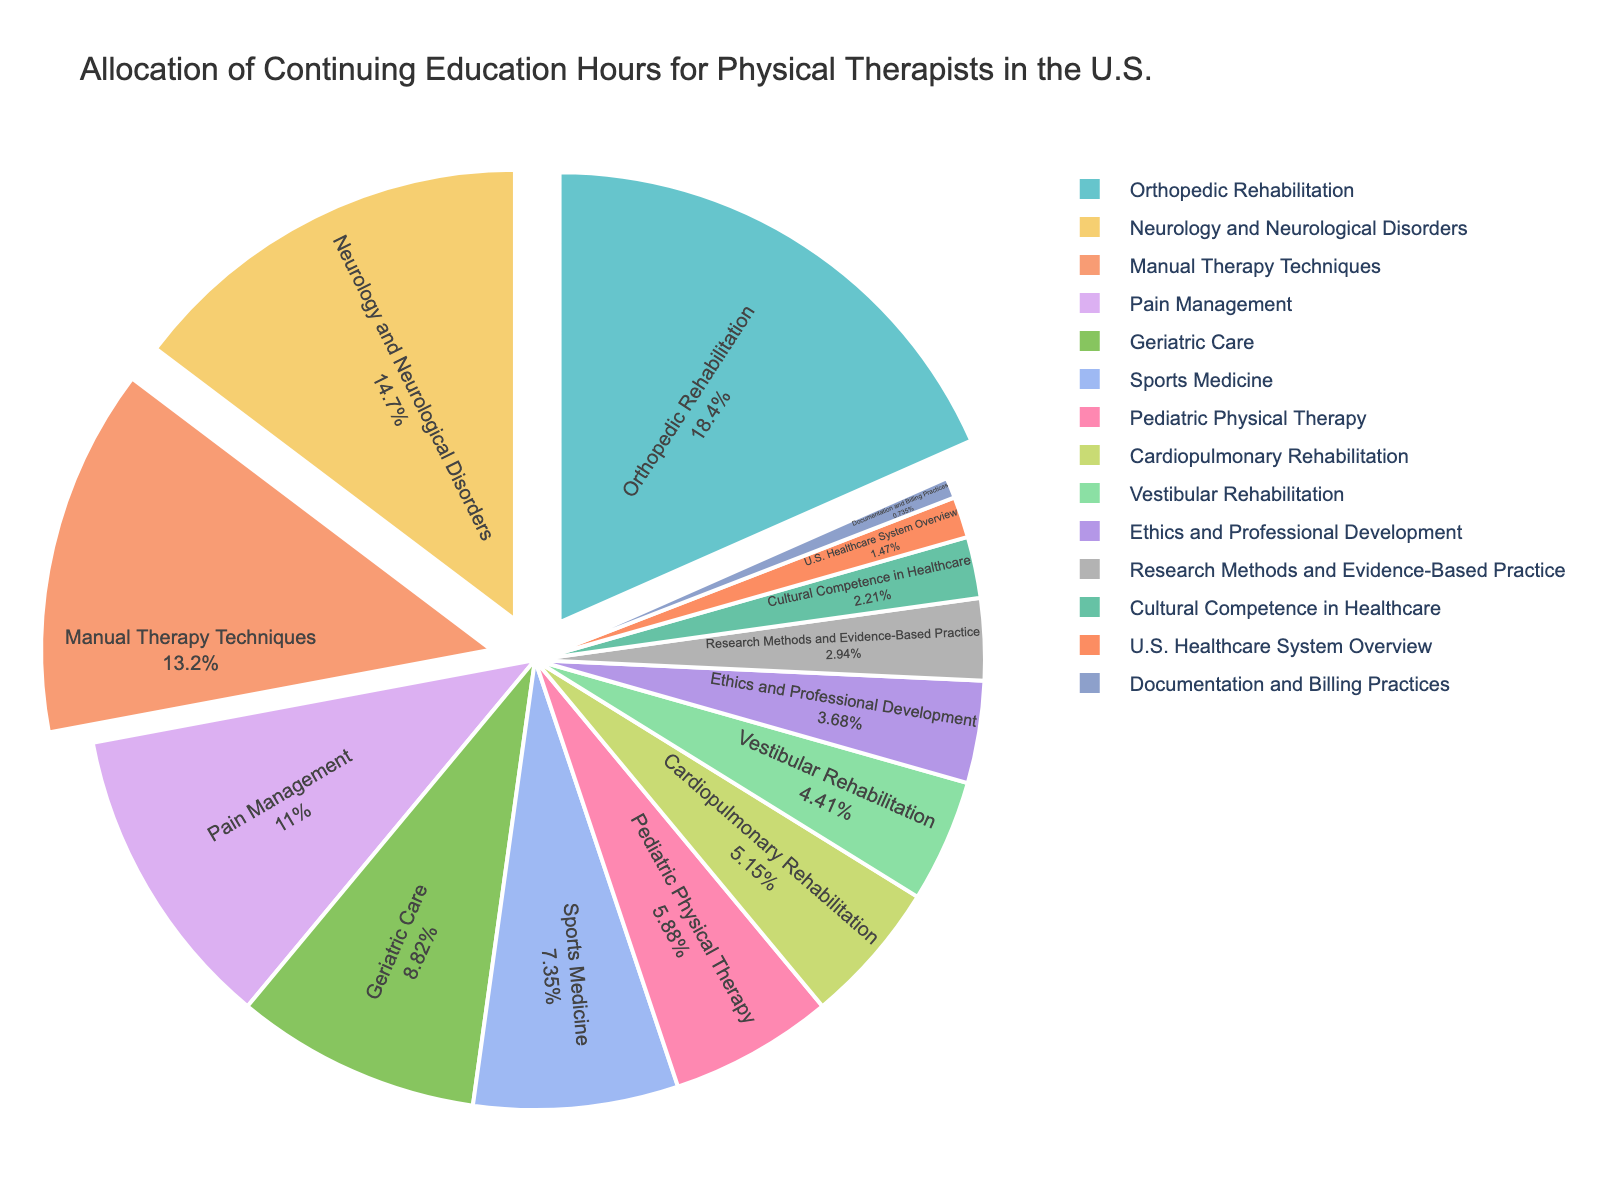What percentage of continuing education hours are allocated to Orthopedic Rehabilitation? Orthopedic Rehabilitation is the subject with the highest allocation. The figure assigns 25 hours out of the total sum of hours provided for all subjects. Calculate the percentage as (25/136) * 100%.
Answer: 18.38% How do the hours allocated to Neurology and Neurological Disorders compare to the hours allocated to Sports Medicine? Neurology and Neurological Disorders have 20 hours allocated, while Sports Medicine has 10. Comparing these values, Neurology and Neurological Disorders have twice as many hours allocated as Sports Medicine.
Answer: Neurology and Neurological Disorders > Sports Medicine (double the hours) Which subject areas are highlighted by being slightly pulled out from the pie chart? The figure details that some subjects are slightly pulled out for emphasis. These subjects are those with the highest allocations: Orthopedic Rehabilitation, Neurology and Neurological Disorders, and Manual Therapy Techniques.
Answer: Orthopedic Rehabilitation, Neurology and Neurological Disorders, Manual Therapy Techniques What's the total percentage of continuing education hours allocated to Pediatric Physical Therapy and Cardiopulmonary Rehabilitation combined? Pediatric Physical Therapy has 8 hours, and Cardiopulmonary Rehabilitation has 7 hours. The sum of these hours is 15. Calculate the combined percentage as (15/136) * 100%.
Answer: 11.03% Is Geriatric Care allocated more hours than Pain Management? Geriatric Care has 12 hours allocated, while Pain Management has 15 hours. Since 12 is less than 15, Geriatric Care has fewer hours than Pain Management.
Answer: No Calculate the difference in allocation hours between Ethics and Professional Development and Research Methods and Evidence-Based Practice. Ethics and Professional Development has 5 hours, while Research Methods and Evidence-Based Practice has 4 hours. The difference is 5 - 4.
Answer: 1 hour Which subject area has the least hours allocated, and what is that value? The figure shows the allocation values, and the least hours allocated is for Documentation and Billing Practices with 1 hour.
Answer: Documentation and Billing Practices, 1 hour How many subject areas are allocated more than 10 hours of continuing education? By reviewing the figure, the subjects with more than 10 hours allocated are: Orthopedic Rehabilitation (25), Neurology and Neurological Disorders (20), Manual Therapy Techniques (18), Pain Management (15), and Geriatric Care (12). Count these subjects.
Answer: 5 What visual cue indicates the importance of the first three subject areas in the pie chart? The first three subject areas (Orthopedic Rehabilitation, Neurology and Neurological Disorders, and Manual Therapy Techniques) are slightly pulled out from the pie chart, emphasizing their higher allocation of education hours.
Answer: They are slightly pulled out What is the total allocation of hours for the top three subject areas combined? The top three subjects are: Orthopedic Rehabilitation (25 hours), Neurology and Neurological Disorders (20 hours), and Manual Therapy Techniques (18 hours). Their total allocation is 25 + 20 + 18.
Answer: 63 hours 